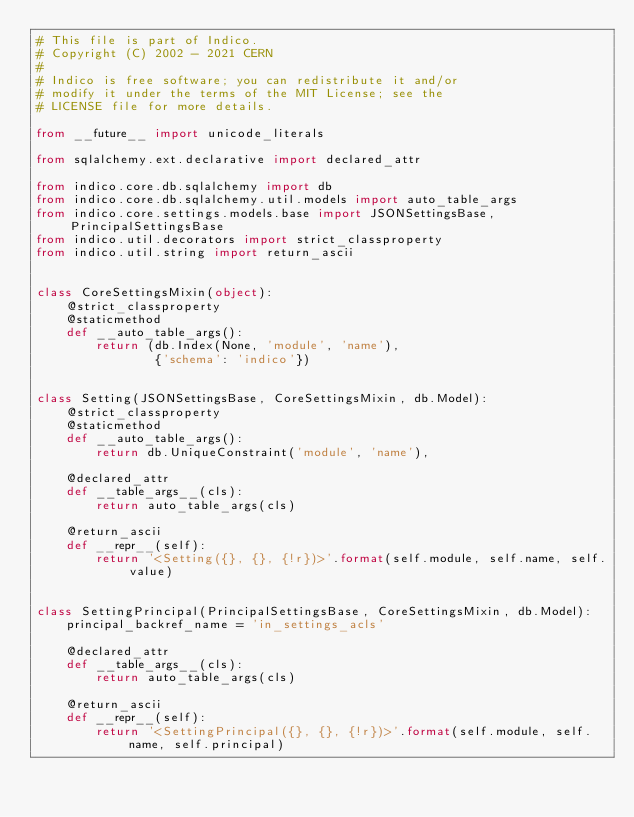<code> <loc_0><loc_0><loc_500><loc_500><_Python_># This file is part of Indico.
# Copyright (C) 2002 - 2021 CERN
#
# Indico is free software; you can redistribute it and/or
# modify it under the terms of the MIT License; see the
# LICENSE file for more details.

from __future__ import unicode_literals

from sqlalchemy.ext.declarative import declared_attr

from indico.core.db.sqlalchemy import db
from indico.core.db.sqlalchemy.util.models import auto_table_args
from indico.core.settings.models.base import JSONSettingsBase, PrincipalSettingsBase
from indico.util.decorators import strict_classproperty
from indico.util.string import return_ascii


class CoreSettingsMixin(object):
    @strict_classproperty
    @staticmethod
    def __auto_table_args():
        return (db.Index(None, 'module', 'name'),
                {'schema': 'indico'})


class Setting(JSONSettingsBase, CoreSettingsMixin, db.Model):
    @strict_classproperty
    @staticmethod
    def __auto_table_args():
        return db.UniqueConstraint('module', 'name'),

    @declared_attr
    def __table_args__(cls):
        return auto_table_args(cls)

    @return_ascii
    def __repr__(self):
        return '<Setting({}, {}, {!r})>'.format(self.module, self.name, self.value)


class SettingPrincipal(PrincipalSettingsBase, CoreSettingsMixin, db.Model):
    principal_backref_name = 'in_settings_acls'

    @declared_attr
    def __table_args__(cls):
        return auto_table_args(cls)

    @return_ascii
    def __repr__(self):
        return '<SettingPrincipal({}, {}, {!r})>'.format(self.module, self.name, self.principal)
</code> 